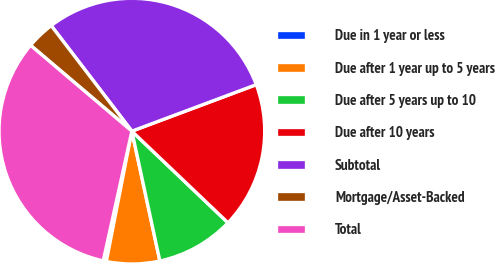Convert chart to OTSL. <chart><loc_0><loc_0><loc_500><loc_500><pie_chart><fcel>Due in 1 year or less<fcel>Due after 1 year up to 5 years<fcel>Due after 5 years up to 10<fcel>Due after 10 years<fcel>Subtotal<fcel>Mortgage/Asset-Backed<fcel>Total<nl><fcel>0.38%<fcel>6.46%<fcel>9.5%<fcel>17.81%<fcel>29.69%<fcel>3.42%<fcel>32.73%<nl></chart> 